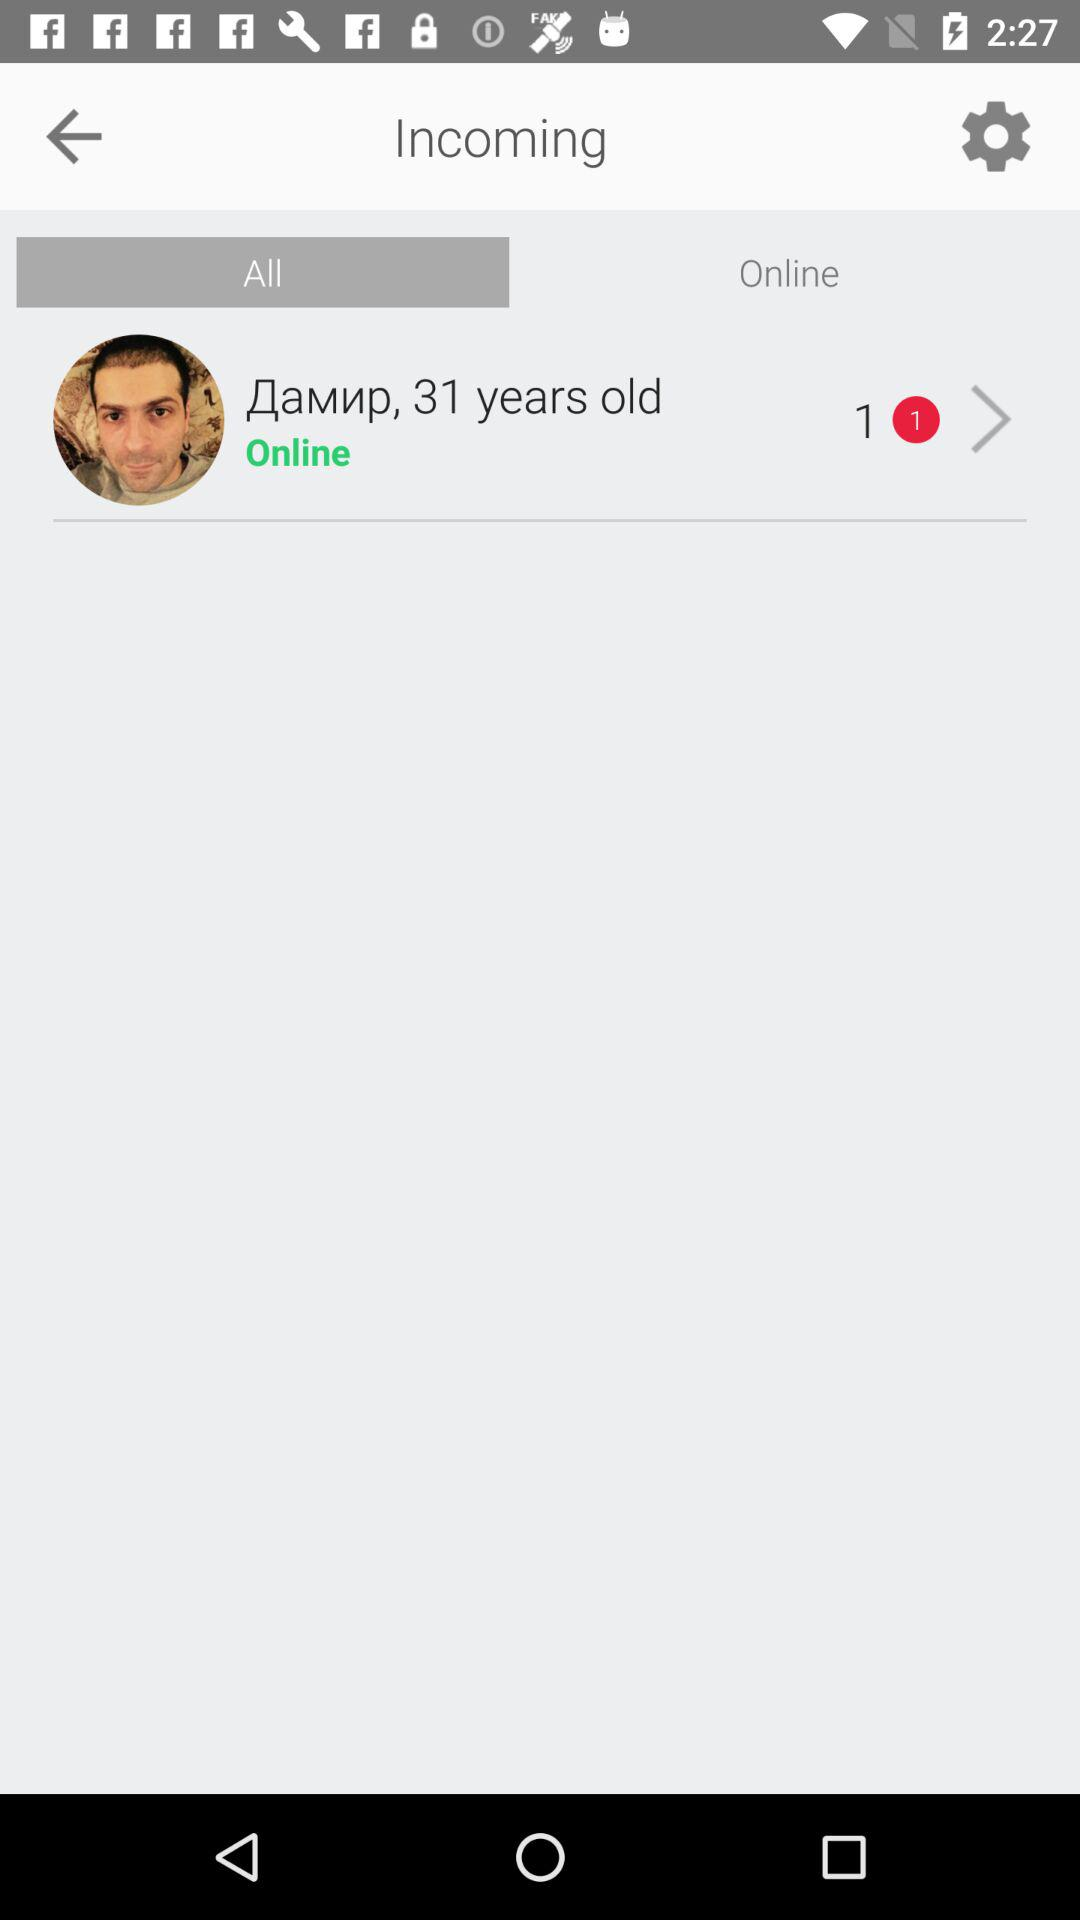Which tab is selected? The selected tab is "All". 